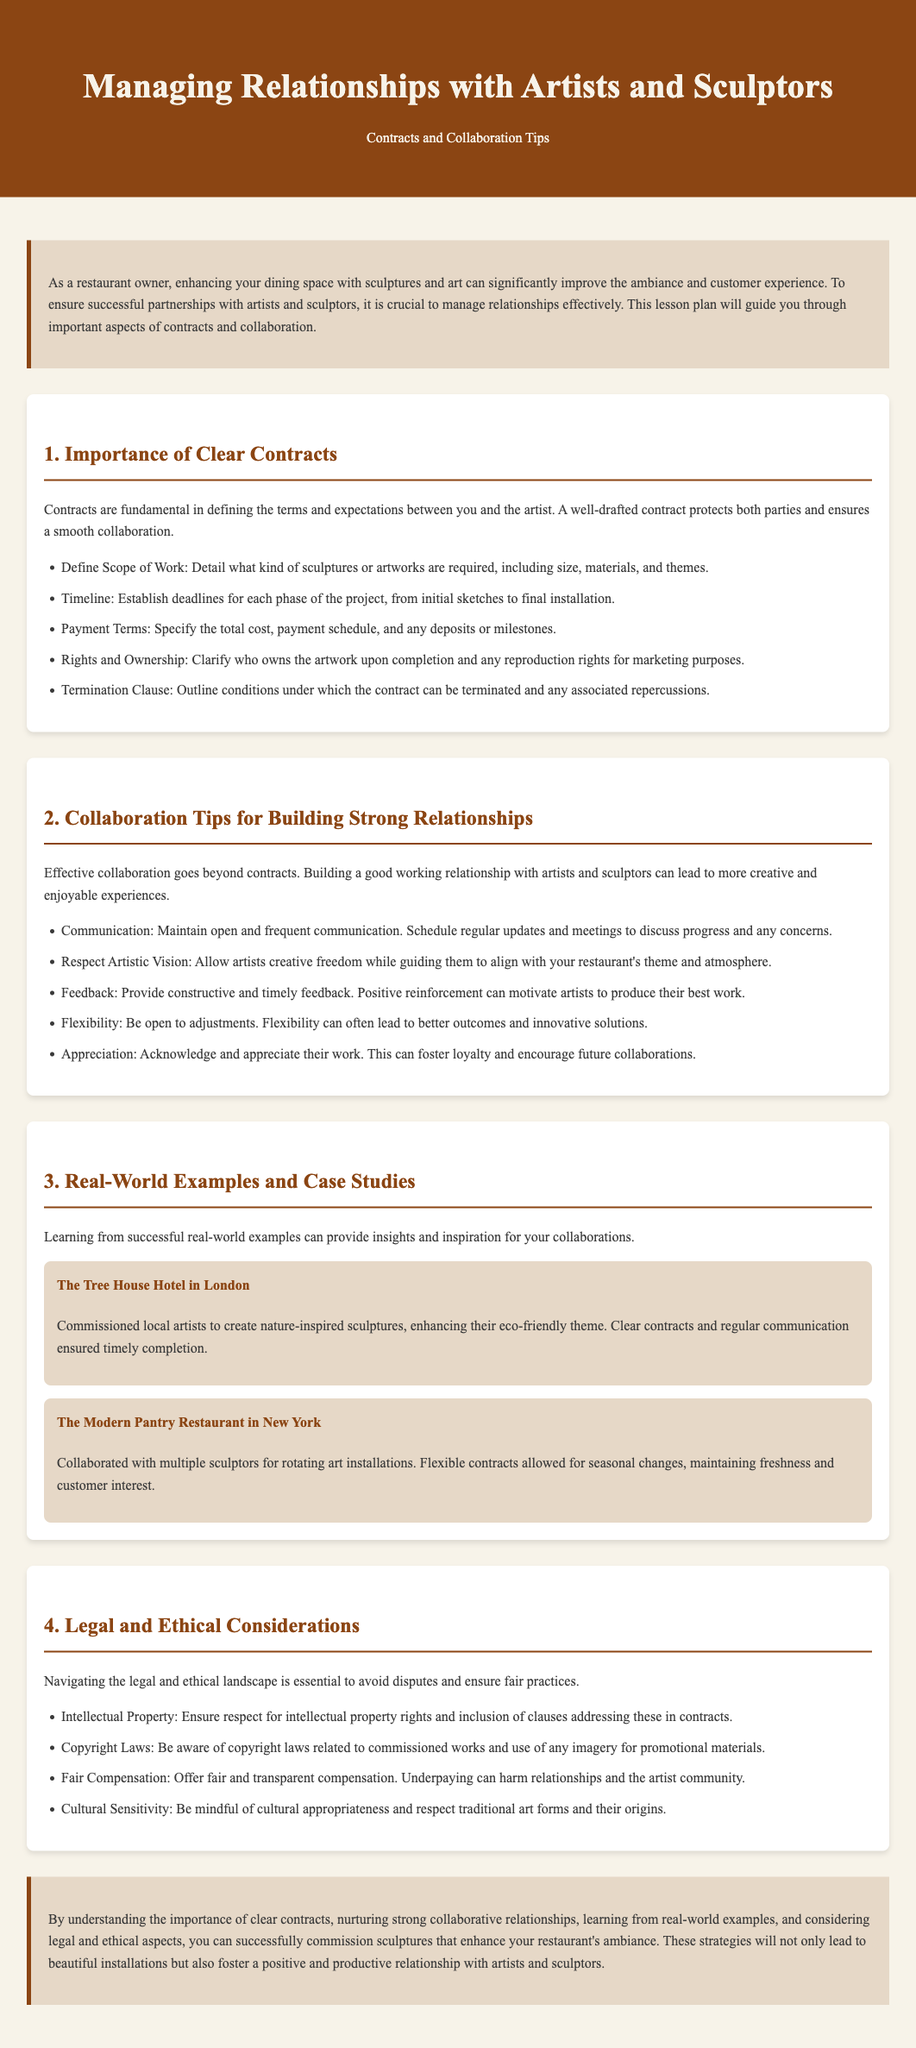What is the main topic of the lesson plan? The primary focus of the document is on managing relationships with artists and sculptors, specifically in the context of contracts and collaboration tips.
Answer: Managing relationships with artists and sculptors What does a well-drafted contract protect? The document states that a well-drafted contract protects both parties involved in the collaboration.
Answer: Both parties What is one aspect to define in a contract? The document lists several aspects, one of which includes detailing the scope of work required for the sculptures.
Answer: Scope of Work Which restaurant is mentioned as having nature-inspired sculptures? The lesson plan includes the Tree House Hotel in London as an example of this type of collaboration.
Answer: The Tree House Hotel in London What is a recommended aspect of effective collaboration? One of the tips for effective collaboration mentioned is maintaining open and frequent communication.
Answer: Communication What should you provide to encourage artists according to the lesson plan? The document advises providing constructive and timely feedback to motivate artists in their work.
Answer: Constructive and timely feedback What cultural aspect should be considered during collaborations? The lesson plan highlights the importance of being mindful of cultural appropriateness and respecting traditional art forms and their origins.
Answer: Cultural Sensitivity How many examples are provided in the document? Two real-world examples of successful collaborations with artists and sculptors are included in the lesson plan.
Answer: Two What is the background color of the document's body? The background color of the body specified in the document is a light beige color with a hex code of #f7f3e9.
Answer: #f7f3e9 